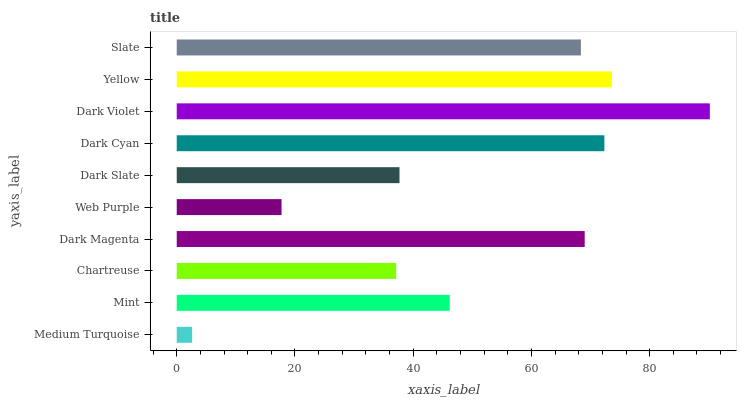Is Medium Turquoise the minimum?
Answer yes or no. Yes. Is Dark Violet the maximum?
Answer yes or no. Yes. Is Mint the minimum?
Answer yes or no. No. Is Mint the maximum?
Answer yes or no. No. Is Mint greater than Medium Turquoise?
Answer yes or no. Yes. Is Medium Turquoise less than Mint?
Answer yes or no. Yes. Is Medium Turquoise greater than Mint?
Answer yes or no. No. Is Mint less than Medium Turquoise?
Answer yes or no. No. Is Slate the high median?
Answer yes or no. Yes. Is Mint the low median?
Answer yes or no. Yes. Is Medium Turquoise the high median?
Answer yes or no. No. Is Medium Turquoise the low median?
Answer yes or no. No. 